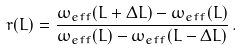Convert formula to latex. <formula><loc_0><loc_0><loc_500><loc_500>r ( L ) = \frac { \omega _ { e f f } ( L + \Delta L ) - \omega _ { e f f } ( L ) } { \omega _ { e f f } ( L ) - \omega _ { e f f } ( L - \Delta L ) } \, .</formula> 